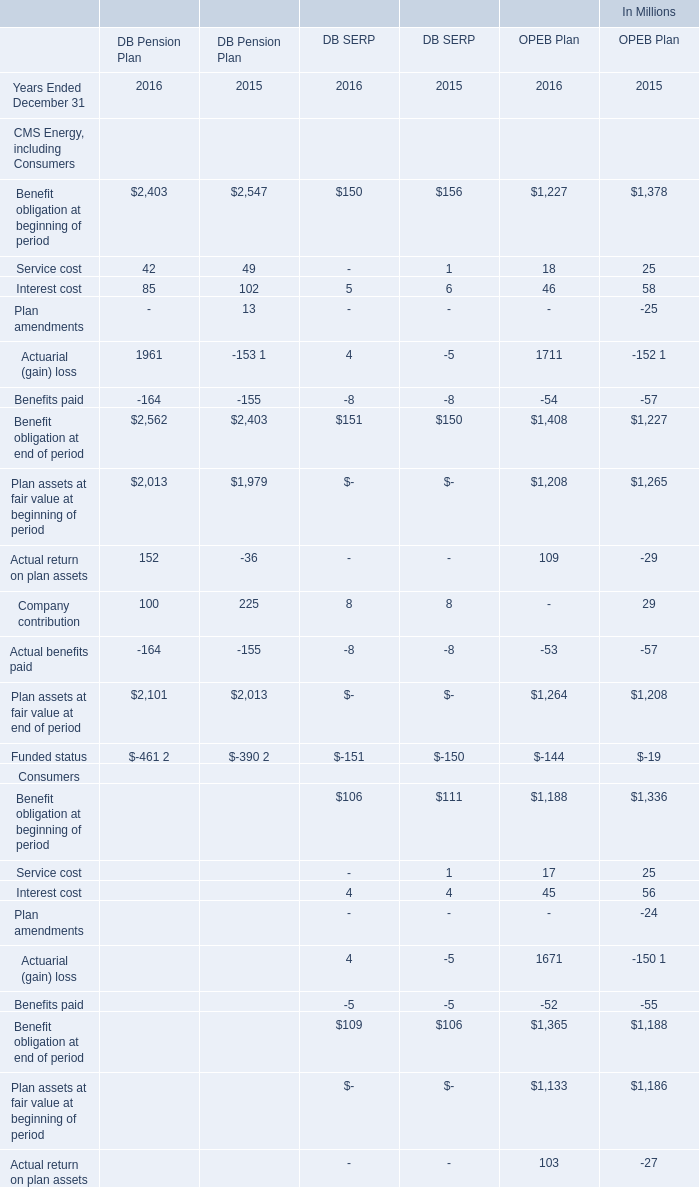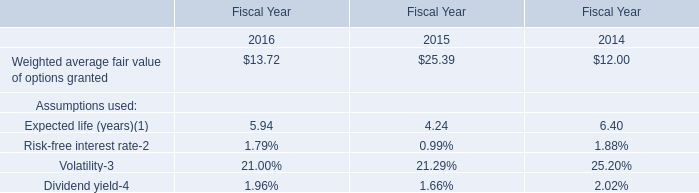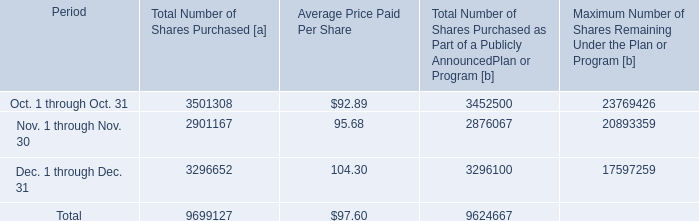What is the percentage of all DB Pension Plan that are positive to the total amount, in 2016? 
Computations: (((((((2403 + 42) + 85) + 1961) + 2013) + 152) + 100) / (2562 + 2101))
Answer: 1.44885. What was the total amount of Benefit obligation at beginning of period greater than 2000 in 2016 for DB Pension Plan ? (in million) 
Answer: 2403. 